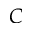Convert formula to latex. <formula><loc_0><loc_0><loc_500><loc_500>C</formula> 